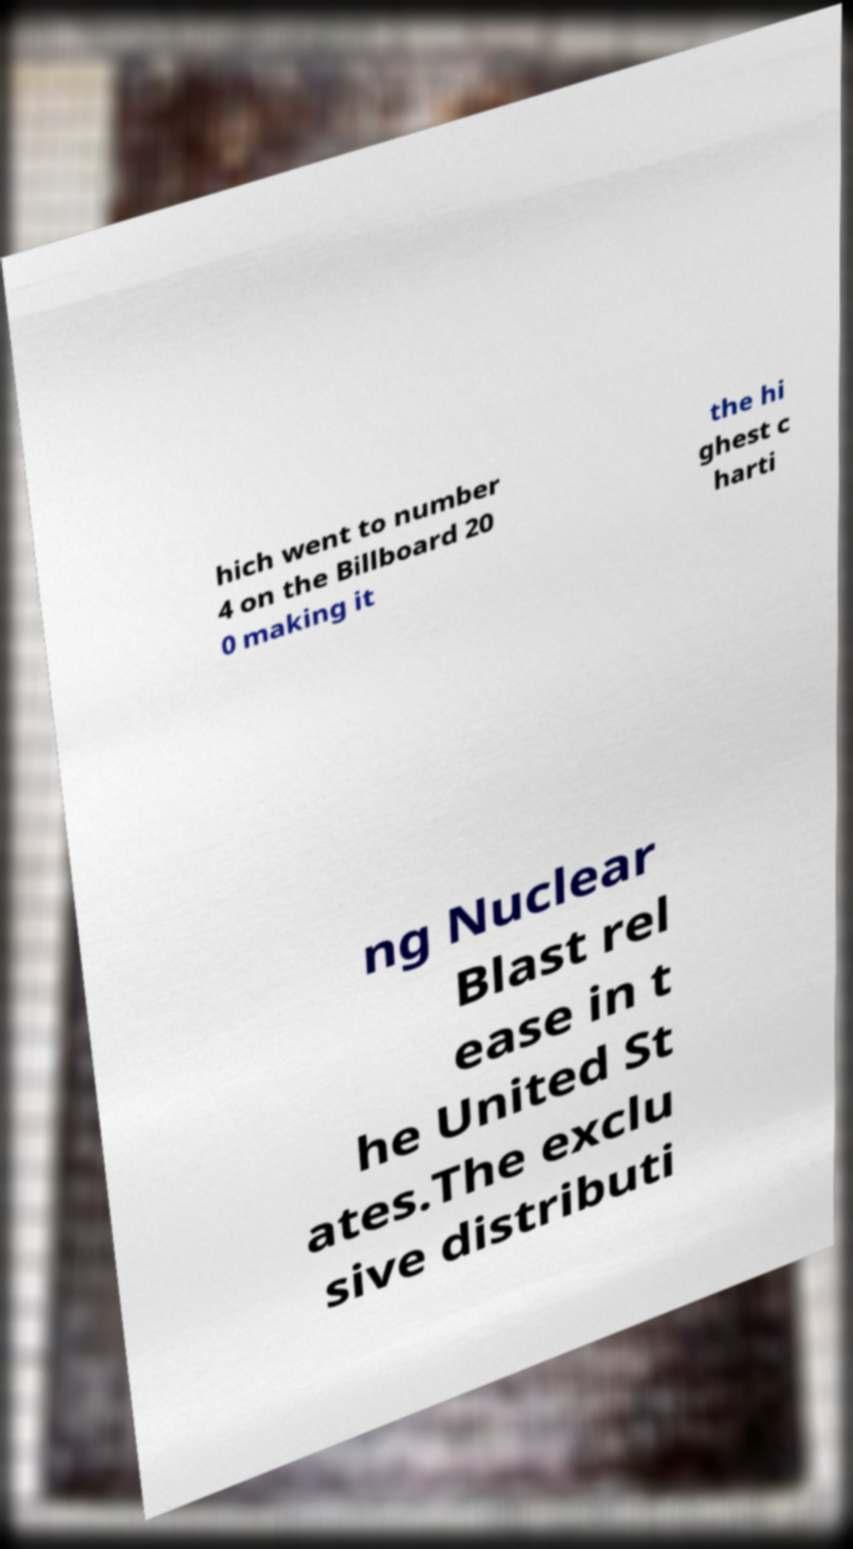There's text embedded in this image that I need extracted. Can you transcribe it verbatim? hich went to number 4 on the Billboard 20 0 making it the hi ghest c harti ng Nuclear Blast rel ease in t he United St ates.The exclu sive distributi 